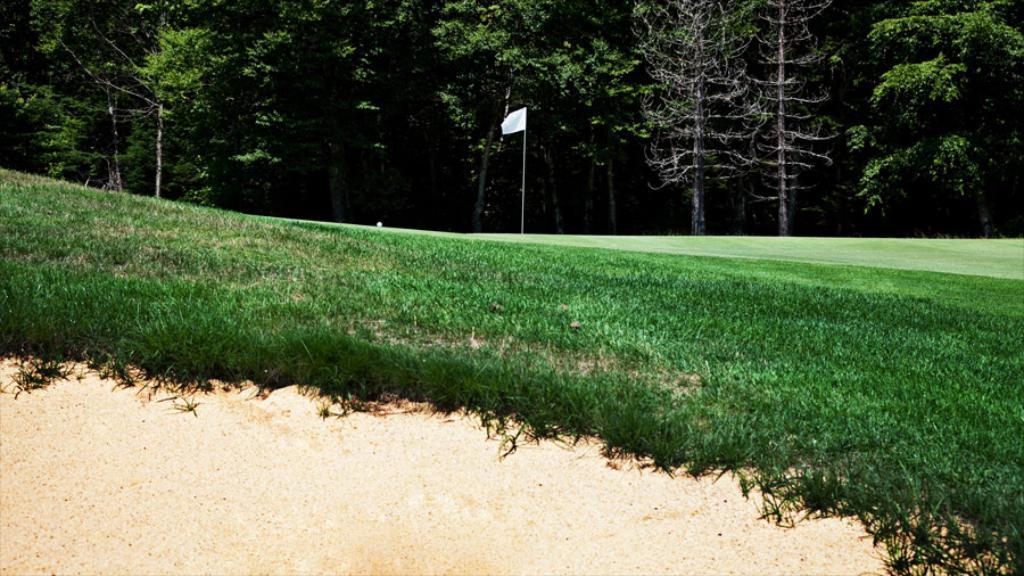How would you summarize this image in a sentence or two? In this picture there is a flag on the ground. At the bottom i can see the grass and sand. In the background i can see many toys. 